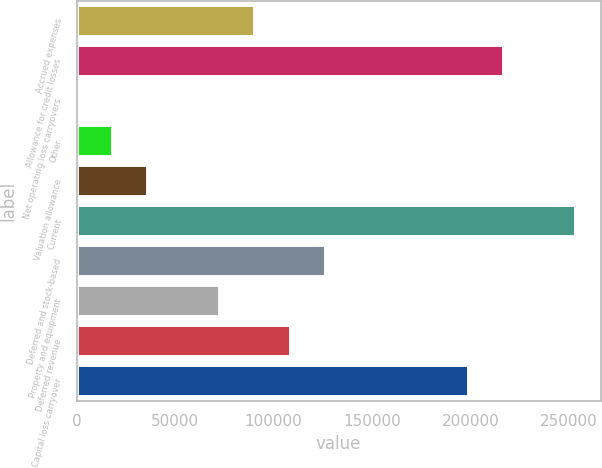Convert chart to OTSL. <chart><loc_0><loc_0><loc_500><loc_500><bar_chart><fcel>Accrued expenses<fcel>Allowance for credit losses<fcel>Net operating loss carryovers<fcel>Other<fcel>Valuation allowance<fcel>Current<fcel>Deferred and stock-based<fcel>Property and equipment<fcel>Deferred revenue<fcel>Capital loss carryover<nl><fcel>90614.5<fcel>217195<fcel>200<fcel>18282.9<fcel>36365.8<fcel>253361<fcel>126780<fcel>72531.6<fcel>108697<fcel>199112<nl></chart> 